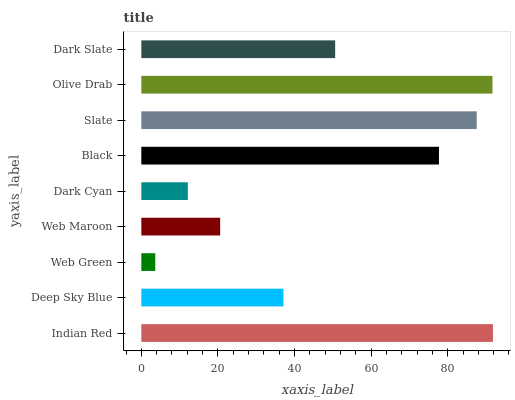Is Web Green the minimum?
Answer yes or no. Yes. Is Indian Red the maximum?
Answer yes or no. Yes. Is Deep Sky Blue the minimum?
Answer yes or no. No. Is Deep Sky Blue the maximum?
Answer yes or no. No. Is Indian Red greater than Deep Sky Blue?
Answer yes or no. Yes. Is Deep Sky Blue less than Indian Red?
Answer yes or no. Yes. Is Deep Sky Blue greater than Indian Red?
Answer yes or no. No. Is Indian Red less than Deep Sky Blue?
Answer yes or no. No. Is Dark Slate the high median?
Answer yes or no. Yes. Is Dark Slate the low median?
Answer yes or no. Yes. Is Indian Red the high median?
Answer yes or no. No. Is Black the low median?
Answer yes or no. No. 